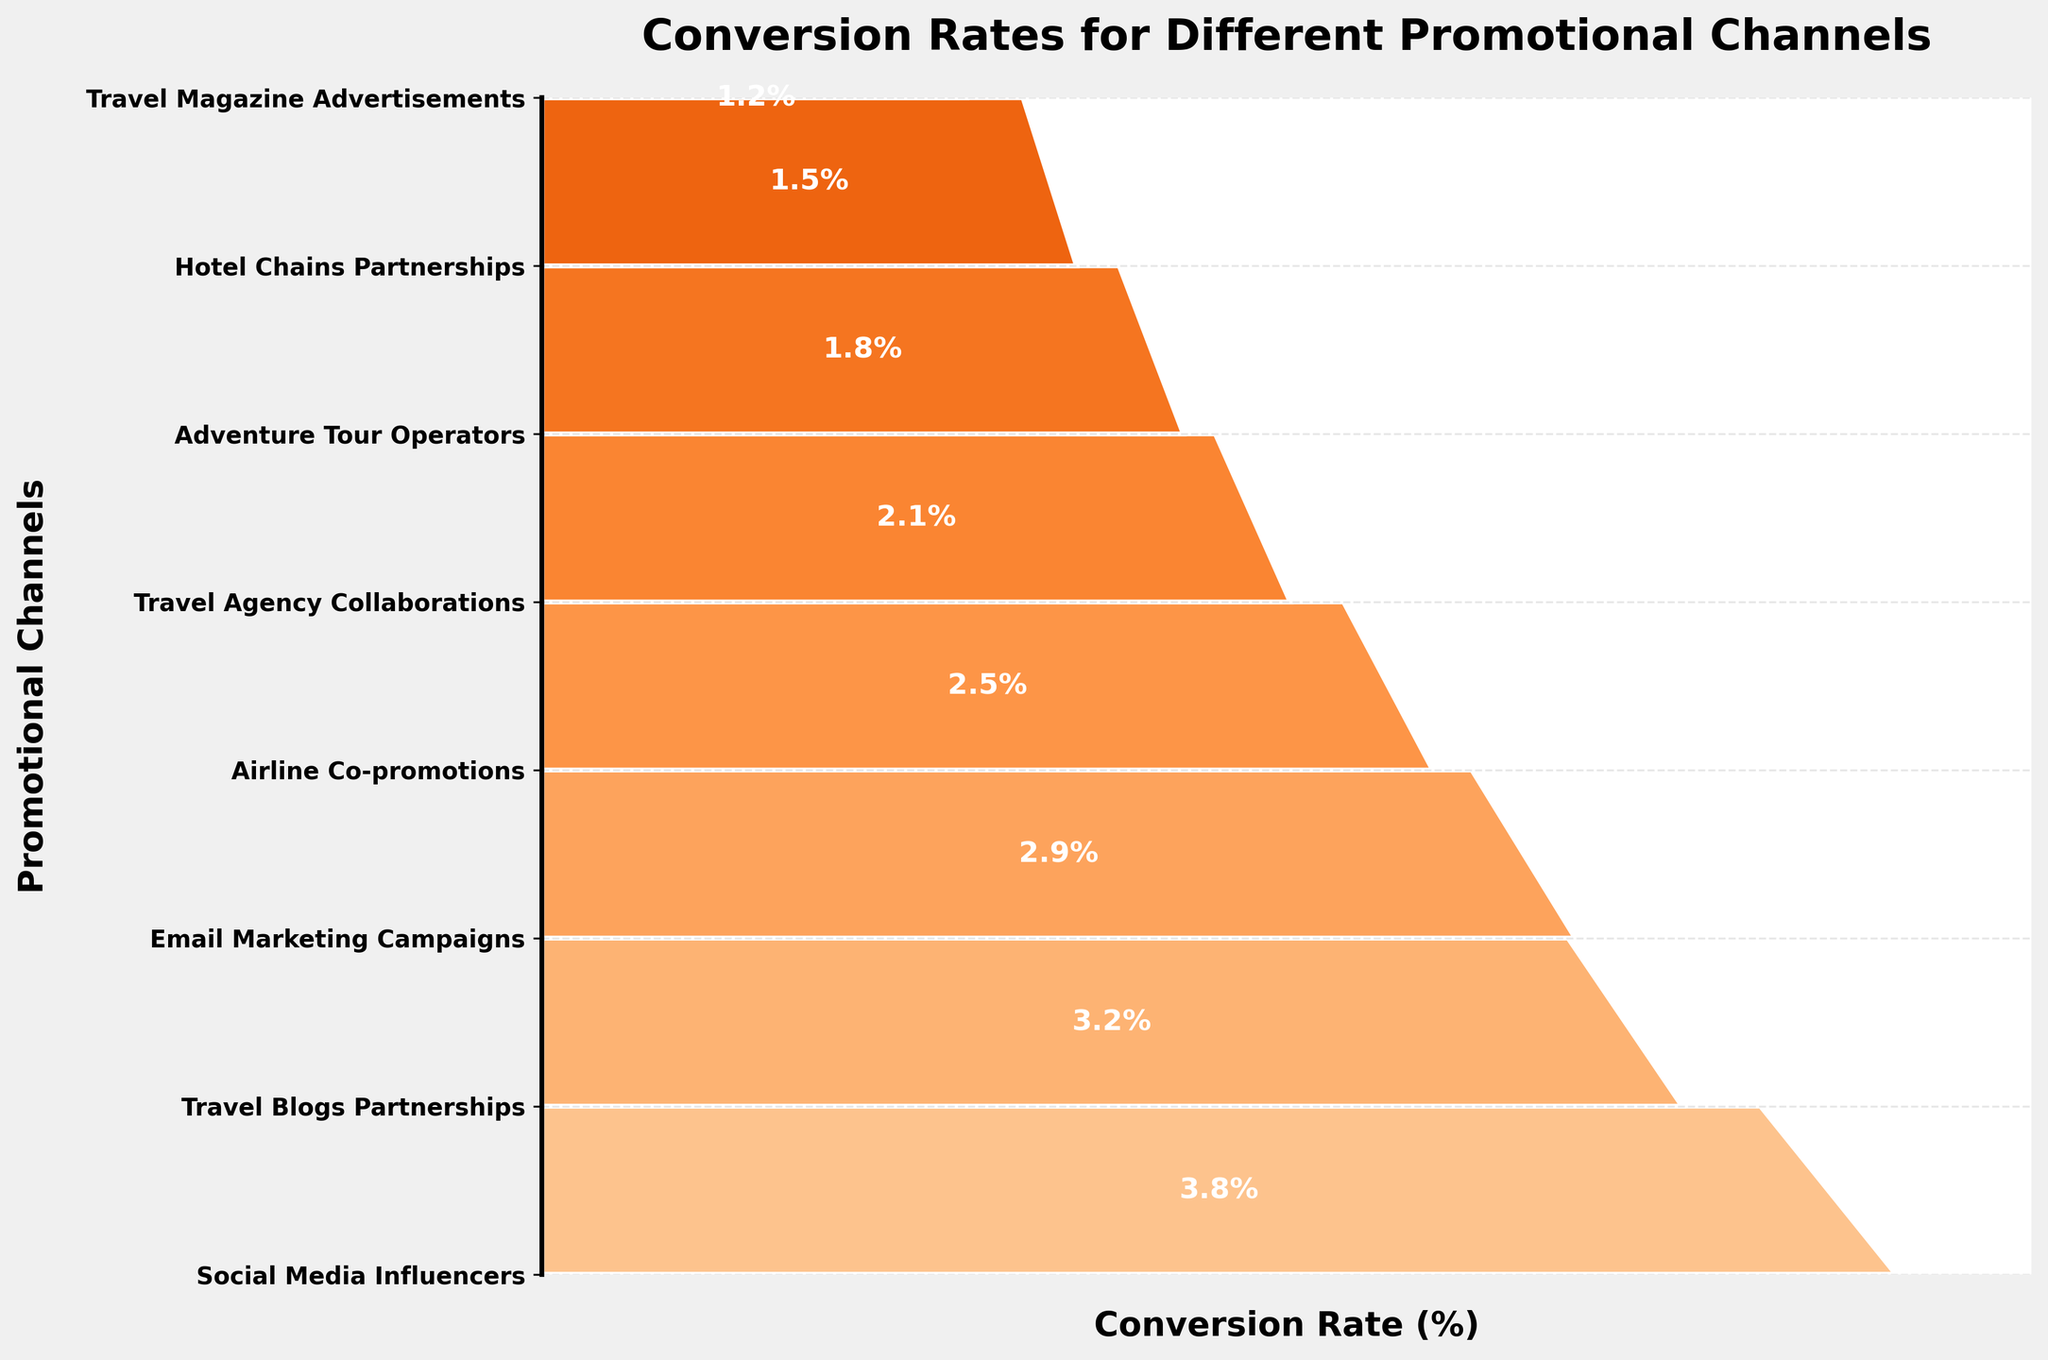what is the highest conversion rate among the promotional channels? The highest conversion rate can be identified by looking for the largest percentage value on the plot, which corresponds to the widest section at the top of the funnel chart.
Answer: 3.8% Which promotional channel has the lowest conversion rate? To identify the lowest conversion rate, look for the smallest percentage value on the plot, corresponding to the narrowest section at the bottom of the funnel chart.
Answer: Travel Magazine Advertisements What is the difference in conversion rates between Social Media Influencers and Travel Magazine Advertisements? The difference can be calculated by subtracting the conversion rate of Travel Magazine Advertisements (1.2%) from that of Social Media Influencers (3.8%).
Answer: 2.6% How many promotional channels have a conversion rate higher than 2%? Count the number of channels with conversion rates listed above 2% on the funnel chart. The relevant channels are: Social Media Influencers (3.8%), Travel Blogs Partnerships (3.2%), Email Marketing Campaigns (2.9%), and Airline Co-promotions (2.5%).
Answer: 4 What is the average conversion rate of the promotional channels? To find the average, sum all the conversion rates and divide by the number of channels: (3.8 + 3.2 + 2.9 + 2.5 + 2.1 + 1.8 + 1.5 + 1.2) / 8.
Answer: 2.375% Which channel performed better: Email Marketing Campaigns or Airline Co-promotions? Compare the conversion rates of Email Marketing Campaigns (2.9%) and Airline Co-promotions (2.5%). The channel with the higher conversion rate performed better.
Answer: Email Marketing Campaigns Rank the top three promotional channels based on conversion rates. Identify the three highest values in the plot and list their corresponding channels. The top three are Social Media Influencers (3.8%), Travel Blogs Partnerships (3.2%), and Email Marketing Campaigns (2.9%).
Answer: Social Media Influencers, Travel Blogs Partnerships, Email Marketing Campaigns What is the combined conversion rate of Travel Blogs Partnerships and Adventure Tour Operators? Sum the conversion rates of Travel Blogs Partnerships (3.2%) and Adventure Tour Operators (1.8%).
Answer: 5% How does the conversion rate of Hotel Chains Partnerships compare to Travel Agency Collaborations? Compare the conversion rates of Hotel Chains Partnerships (1.5%) and Travel Agency Collaborations (2.1%).
Answer: Travel Agency Collaborations is higher What is the median conversion rate of all the promotional channels? The median is the middle value when the rates are ordered. The ordered list is: 1.2, 1.5, 1.8, 2.1, 2.5, 2.9, 3.2, 3.8. The middle values are 2.1 and 2.5, so the median is the average of these two: (2.1 + 2.5) / 2.
Answer: 2.3% 